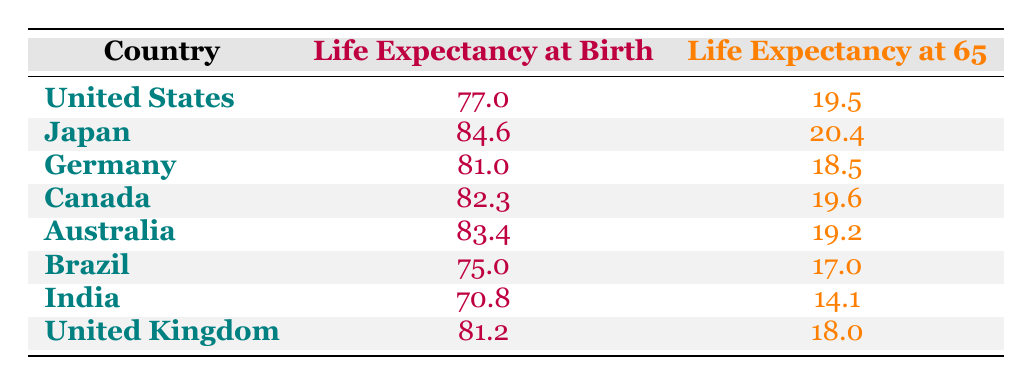What is the life expectancy at birth in Japan? The life expectancy at birth for Japan is listed in the table as 84.6 years.
Answer: 84.6 Which country has the lowest life expectancy at 65? The country with the lowest life expectancy at 65 is India, with a value of 14.1 years as indicated in the table.
Answer: India What is the difference between life expectancy at birth and life expectancy at 65 for Canada? For Canada, life expectancy at birth is 82.3 and life expectancy at 65 is 19.6. To find the difference, we subtract 19.6 from 82.3, which gives us 62.7.
Answer: 62.7 Is the life expectancy at birth in Brazil greater than that in the United Kingdom? The life expectancy at birth in Brazil is 75.0 and in the United Kingdom, it is 81.2. Since 75.0 is less than 81.2, the statement is false.
Answer: No What is the average life expectancy at birth for the countries listed in the table? To find the average, we first list all the life expectancies at birth: 77.0, 84.6, 81.0, 82.3, 83.4, 75.0, 70.8, 81.2. Adding these gives a total of 9.1. There are 8 countries, so we divide 9.1 by 8, resulting in an average of approximately 78.4.
Answer: 78.4 Which country has the highest life expectancy at 65? The country with the highest life expectancy at 65 is Japan, with a value of 20.4 years as shown in the table.
Answer: Japan If we compare Mexico and India regarding life expectancy at birth, which one has better longevity? Since we do not have data for Mexico in the provided table, we can only compare India, which has a life expectancy at birth of 70.8. Without Mexico's data, we cannot conclude which has the better longevity. Therefore, the answer is inconclusive.
Answer: Inconclusive What is the total life expectancy at birth for the countries listed? To find the total, we sum the life expectancies at birth: 77.0 + 84.6 + 81.0 + 82.3 + 83.4 + 75.0 + 70.8 + 81.2 = 635.3 years.
Answer: 635.3 